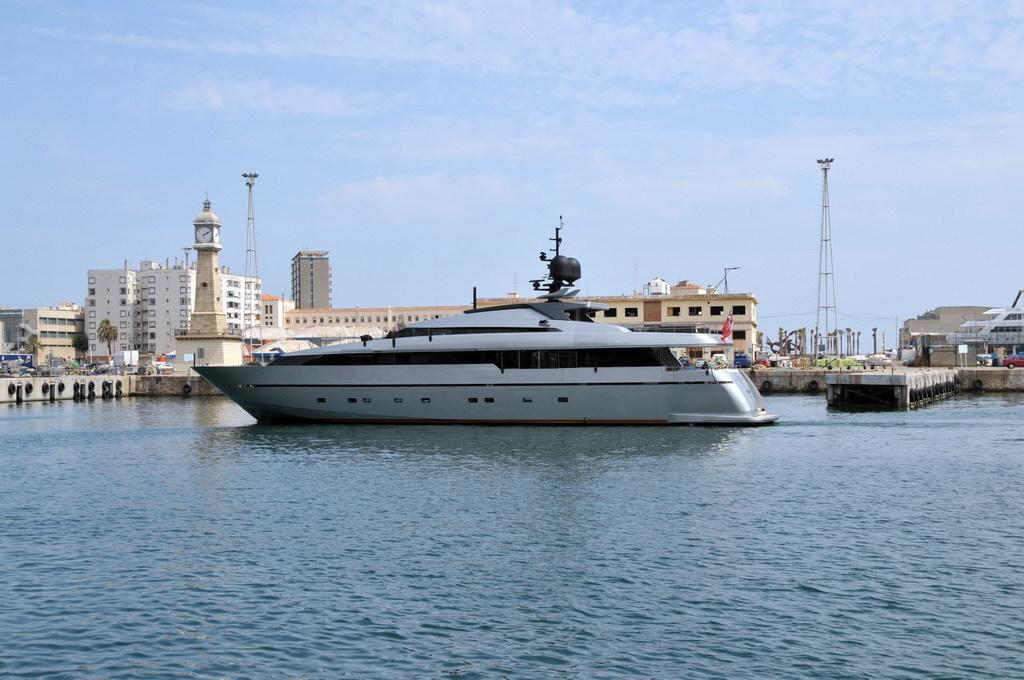Can you describe this image briefly? Here in this picture in the middle we can see a boat present in the water covered over there and beside that we can see number of buildings and stores present and we can also see towers present and we can also see plants and trees also present and we can see clouds in the sky. 